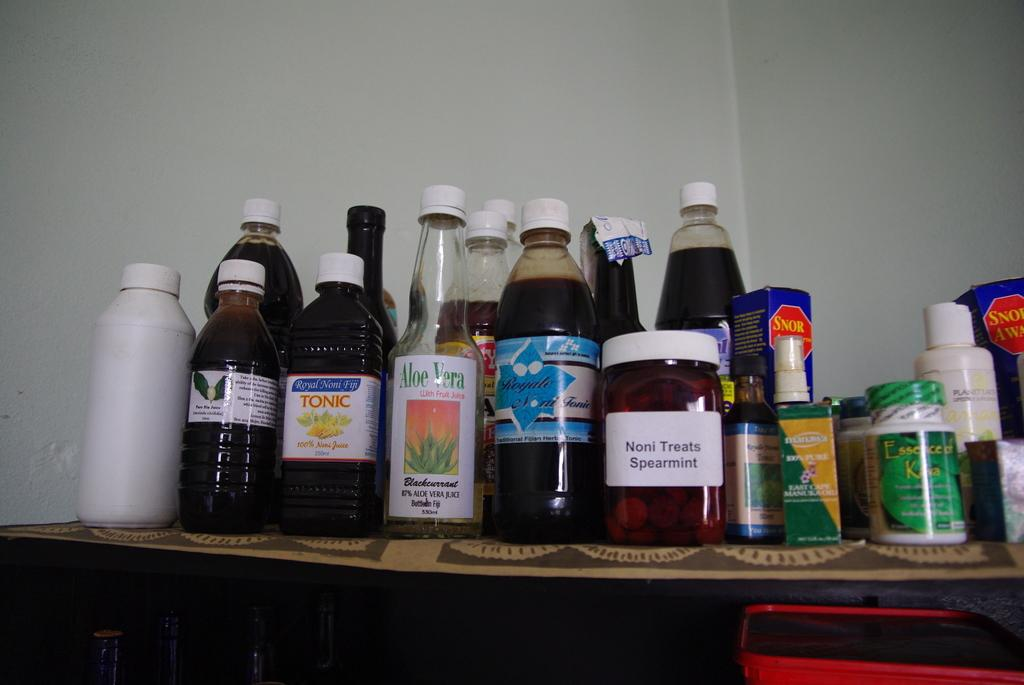What is present on the table in the image? There are many bottles on a table in the image. Can you identify any specific type of bottle? Yes, one of the bottles has the words "aloe vera" written on it. What can be seen behind the table in the image? There is a white wall behind the table. How many ducks are swimming in the soup in the image? There is no soup or ducks present in the image; it features a table with many bottles and a white wall in the background. 